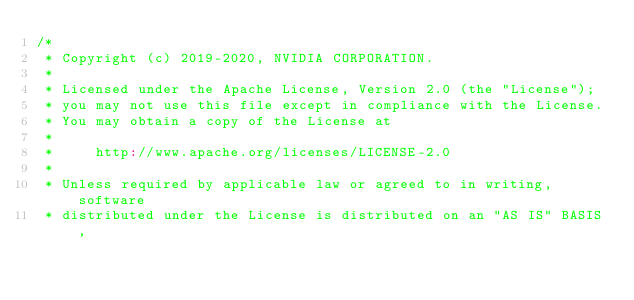Convert code to text. <code><loc_0><loc_0><loc_500><loc_500><_Scala_>/*
 * Copyright (c) 2019-2020, NVIDIA CORPORATION.
 *
 * Licensed under the Apache License, Version 2.0 (the "License");
 * you may not use this file except in compliance with the License.
 * You may obtain a copy of the License at
 *
 *     http://www.apache.org/licenses/LICENSE-2.0
 *
 * Unless required by applicable law or agreed to in writing, software
 * distributed under the License is distributed on an "AS IS" BASIS,</code> 